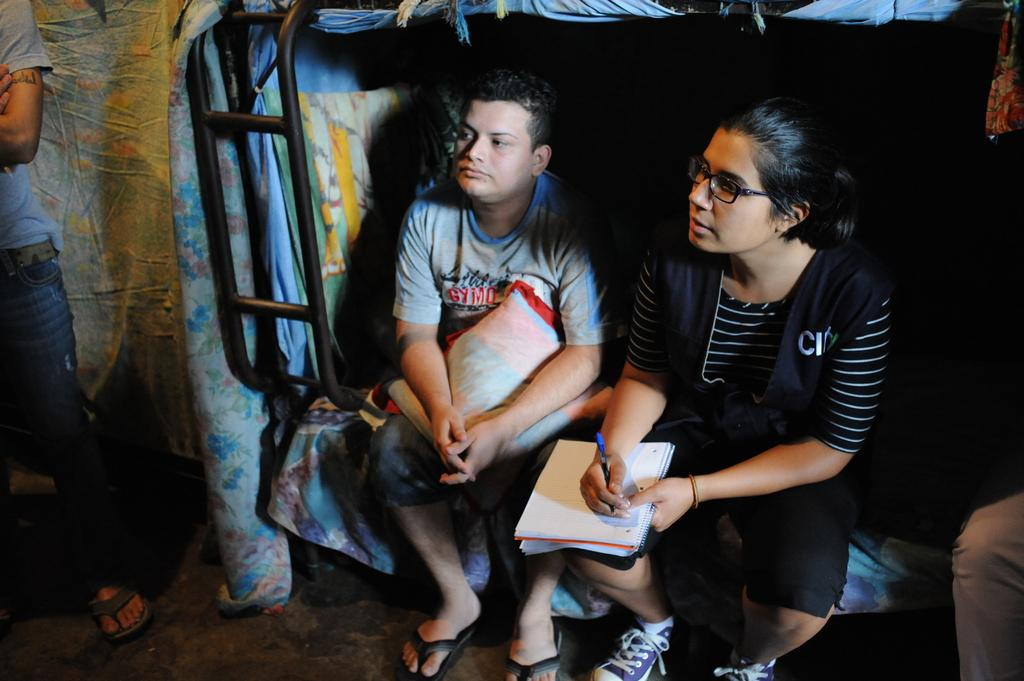How many people are sitting in the image? There are two persons sitting in the image. What is the position of the person standing in the image? The person standing is on the left side of the image. What is the woman on the right side of the image holding? The woman is holding a book, a pen, and a pillow. What type of grain can be seen growing in the image? There is no grain visible in the image. How many frogs are hopping around in the image? There are no frogs present in the image. 